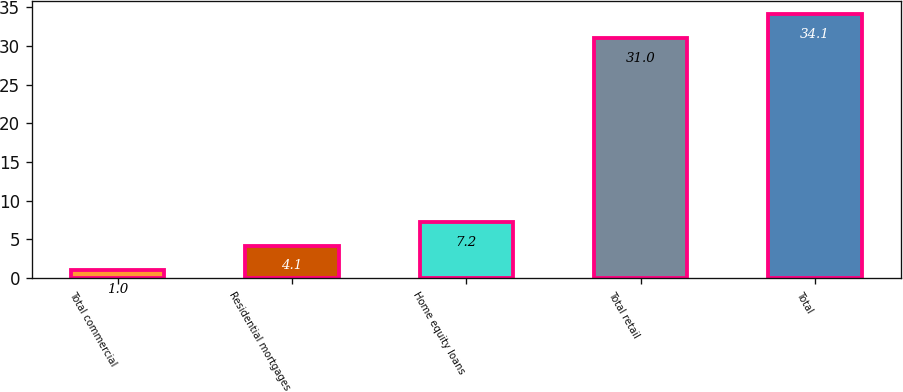Convert chart to OTSL. <chart><loc_0><loc_0><loc_500><loc_500><bar_chart><fcel>Total commercial<fcel>Residential mortgages<fcel>Home equity loans<fcel>Total retail<fcel>Total<nl><fcel>1<fcel>4.1<fcel>7.2<fcel>31<fcel>34.1<nl></chart> 